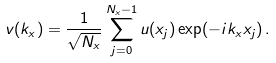<formula> <loc_0><loc_0><loc_500><loc_500>v ( k _ { x } ) = \frac { 1 } { \sqrt { N _ { x } } } \sum _ { j = 0 } ^ { N _ { x } - 1 } u ( x _ { j } ) \exp ( - i k _ { x } x _ { j } ) \, . \\</formula> 